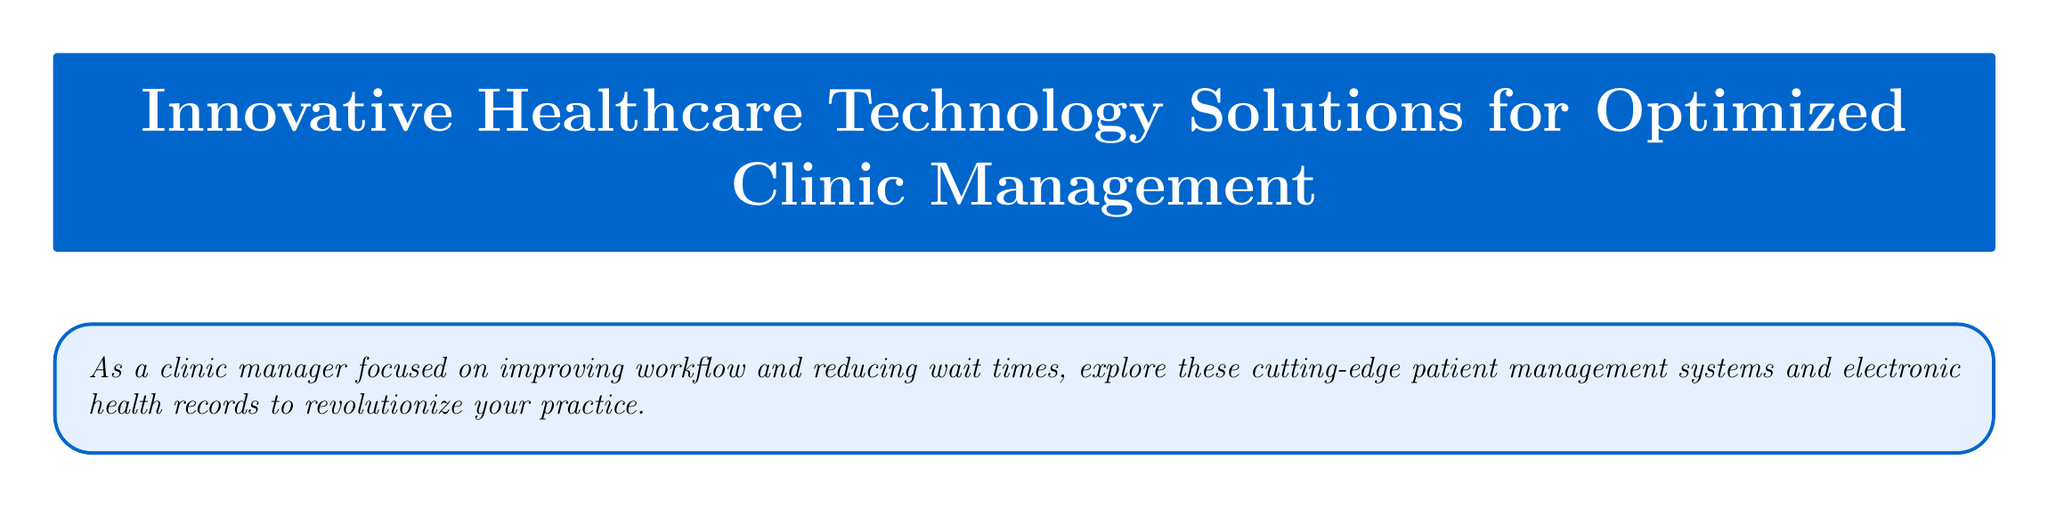what is the title of the catalog? The title is prominently displayed at the top of the document, which is "Innovative Healthcare Technology Solutions for Optimized Clinic Management."
Answer: Innovative Healthcare Technology Solutions for Optimized Clinic Management how much was the reduction in patient wait times at Cornerstone Family Practice? The document states a specific percentage reduction in wait times as a result of implementing the technology, which is 30%.
Answer: 30% which EHR system has a mobile-first design? The document specifies that Cerner PowerChart Touch is a mobile-first EHR solution.
Answer: Cerner PowerChart Touch what feature does Athenahealth athenaClinicals provide for scheduling? The document highlights that Athenahealth includes predictive scheduling algorithms as a feature.
Answer: Predictive scheduling algorithms how can you contact the healthcare solutions provider? The contact information section provides various methods to reach them, including phone, email, and website.
Answer: +1 (800) 555-1234 what was the increase in appointment capacity at Cornerstone Family Practice? The document provides a specific percentage increase in appointment capacity resulting from the technology implementation, which is 25%.
Answer: 25% what functionality does Cerner PowerChart Touch offer to reduce documentation time? The document mentions that Cerner PowerChart Touch has voice-to-text functionality to streamline documentation.
Answer: Voice-to-text functionality what type of reminders does Athenahealth athenaClinicals automate? The document indicates that Athenahealth automates patient reminders as part of its features.
Answer: Automated patient reminders 